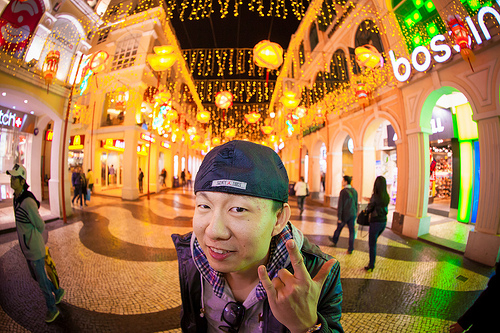<image>
Is there a woman behind the man? Yes. From this viewpoint, the woman is positioned behind the man, with the man partially or fully occluding the woman. Is the man next to the woman? Yes. The man is positioned adjacent to the woman, located nearby in the same general area. 